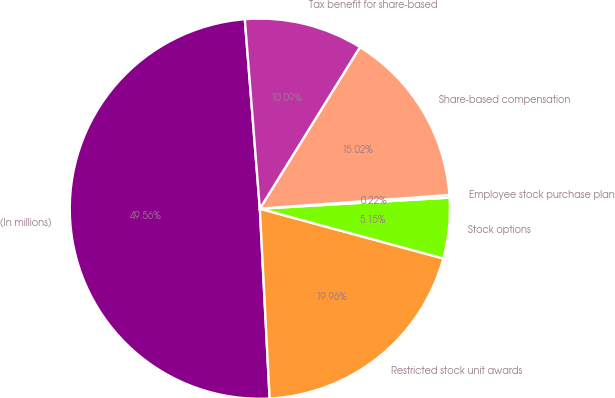Convert chart to OTSL. <chart><loc_0><loc_0><loc_500><loc_500><pie_chart><fcel>(In millions)<fcel>Restricted stock unit awards<fcel>Stock options<fcel>Employee stock purchase plan<fcel>Share-based compensation<fcel>Tax benefit for share-based<nl><fcel>49.56%<fcel>19.96%<fcel>5.15%<fcel>0.22%<fcel>15.02%<fcel>10.09%<nl></chart> 